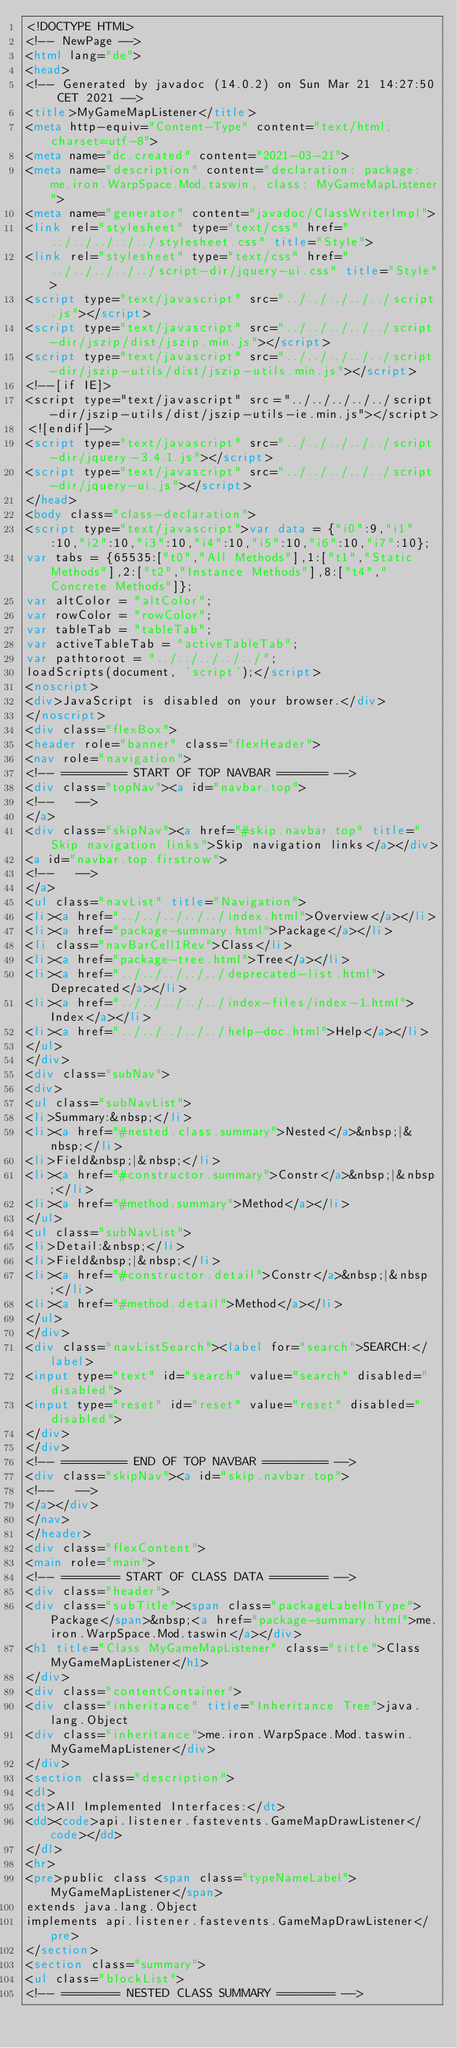Convert code to text. <code><loc_0><loc_0><loc_500><loc_500><_HTML_><!DOCTYPE HTML>
<!-- NewPage -->
<html lang="de">
<head>
<!-- Generated by javadoc (14.0.2) on Sun Mar 21 14:27:50 CET 2021 -->
<title>MyGameMapListener</title>
<meta http-equiv="Content-Type" content="text/html; charset=utf-8">
<meta name="dc.created" content="2021-03-21">
<meta name="description" content="declaration: package: me.iron.WarpSpace.Mod.taswin, class: MyGameMapListener">
<meta name="generator" content="javadoc/ClassWriterImpl">
<link rel="stylesheet" type="text/css" href="../../../../../stylesheet.css" title="Style">
<link rel="stylesheet" type="text/css" href="../../../../../script-dir/jquery-ui.css" title="Style">
<script type="text/javascript" src="../../../../../script.js"></script>
<script type="text/javascript" src="../../../../../script-dir/jszip/dist/jszip.min.js"></script>
<script type="text/javascript" src="../../../../../script-dir/jszip-utils/dist/jszip-utils.min.js"></script>
<!--[if IE]>
<script type="text/javascript" src="../../../../../script-dir/jszip-utils/dist/jszip-utils-ie.min.js"></script>
<![endif]-->
<script type="text/javascript" src="../../../../../script-dir/jquery-3.4.1.js"></script>
<script type="text/javascript" src="../../../../../script-dir/jquery-ui.js"></script>
</head>
<body class="class-declaration">
<script type="text/javascript">var data = {"i0":9,"i1":10,"i2":10,"i3":10,"i4":10,"i5":10,"i6":10,"i7":10};
var tabs = {65535:["t0","All Methods"],1:["t1","Static Methods"],2:["t2","Instance Methods"],8:["t4","Concrete Methods"]};
var altColor = "altColor";
var rowColor = "rowColor";
var tableTab = "tableTab";
var activeTableTab = "activeTableTab";
var pathtoroot = "../../../../../";
loadScripts(document, 'script');</script>
<noscript>
<div>JavaScript is disabled on your browser.</div>
</noscript>
<div class="flexBox">
<header role="banner" class="flexHeader">
<nav role="navigation">
<!-- ========= START OF TOP NAVBAR ======= -->
<div class="topNav"><a id="navbar.top">
<!--   -->
</a>
<div class="skipNav"><a href="#skip.navbar.top" title="Skip navigation links">Skip navigation links</a></div>
<a id="navbar.top.firstrow">
<!--   -->
</a>
<ul class="navList" title="Navigation">
<li><a href="../../../../../index.html">Overview</a></li>
<li><a href="package-summary.html">Package</a></li>
<li class="navBarCell1Rev">Class</li>
<li><a href="package-tree.html">Tree</a></li>
<li><a href="../../../../../deprecated-list.html">Deprecated</a></li>
<li><a href="../../../../../index-files/index-1.html">Index</a></li>
<li><a href="../../../../../help-doc.html">Help</a></li>
</ul>
</div>
<div class="subNav">
<div>
<ul class="subNavList">
<li>Summary:&nbsp;</li>
<li><a href="#nested.class.summary">Nested</a>&nbsp;|&nbsp;</li>
<li>Field&nbsp;|&nbsp;</li>
<li><a href="#constructor.summary">Constr</a>&nbsp;|&nbsp;</li>
<li><a href="#method.summary">Method</a></li>
</ul>
<ul class="subNavList">
<li>Detail:&nbsp;</li>
<li>Field&nbsp;|&nbsp;</li>
<li><a href="#constructor.detail">Constr</a>&nbsp;|&nbsp;</li>
<li><a href="#method.detail">Method</a></li>
</ul>
</div>
<div class="navListSearch"><label for="search">SEARCH:</label>
<input type="text" id="search" value="search" disabled="disabled">
<input type="reset" id="reset" value="reset" disabled="disabled">
</div>
</div>
<!-- ========= END OF TOP NAVBAR ========= -->
<div class="skipNav"><a id="skip.navbar.top">
<!--   -->
</a></div>
</nav>
</header>
<div class="flexContent">
<main role="main">
<!-- ======== START OF CLASS DATA ======== -->
<div class="header">
<div class="subTitle"><span class="packageLabelInType">Package</span>&nbsp;<a href="package-summary.html">me.iron.WarpSpace.Mod.taswin</a></div>
<h1 title="Class MyGameMapListener" class="title">Class MyGameMapListener</h1>
</div>
<div class="contentContainer">
<div class="inheritance" title="Inheritance Tree">java.lang.Object
<div class="inheritance">me.iron.WarpSpace.Mod.taswin.MyGameMapListener</div>
</div>
<section class="description">
<dl>
<dt>All Implemented Interfaces:</dt>
<dd><code>api.listener.fastevents.GameMapDrawListener</code></dd>
</dl>
<hr>
<pre>public class <span class="typeNameLabel">MyGameMapListener</span>
extends java.lang.Object
implements api.listener.fastevents.GameMapDrawListener</pre>
</section>
<section class="summary">
<ul class="blockList">
<!-- ======== NESTED CLASS SUMMARY ======== --></code> 